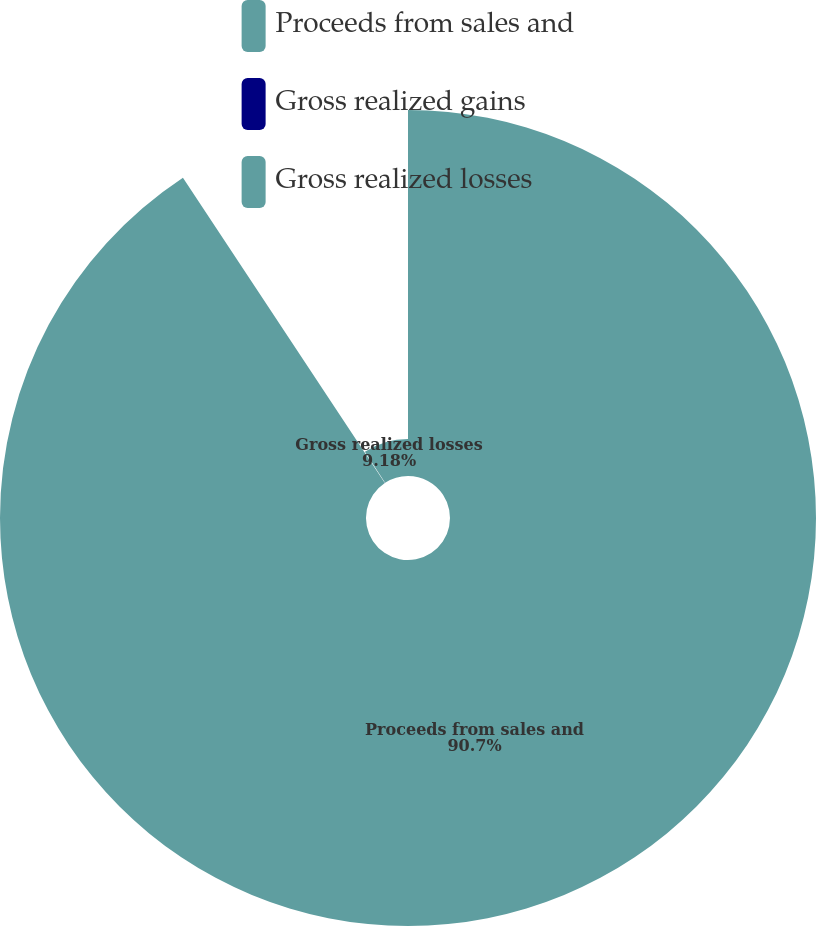Convert chart to OTSL. <chart><loc_0><loc_0><loc_500><loc_500><pie_chart><fcel>Proceeds from sales and<fcel>Gross realized gains<fcel>Gross realized losses<nl><fcel>90.7%<fcel>0.12%<fcel>9.18%<nl></chart> 